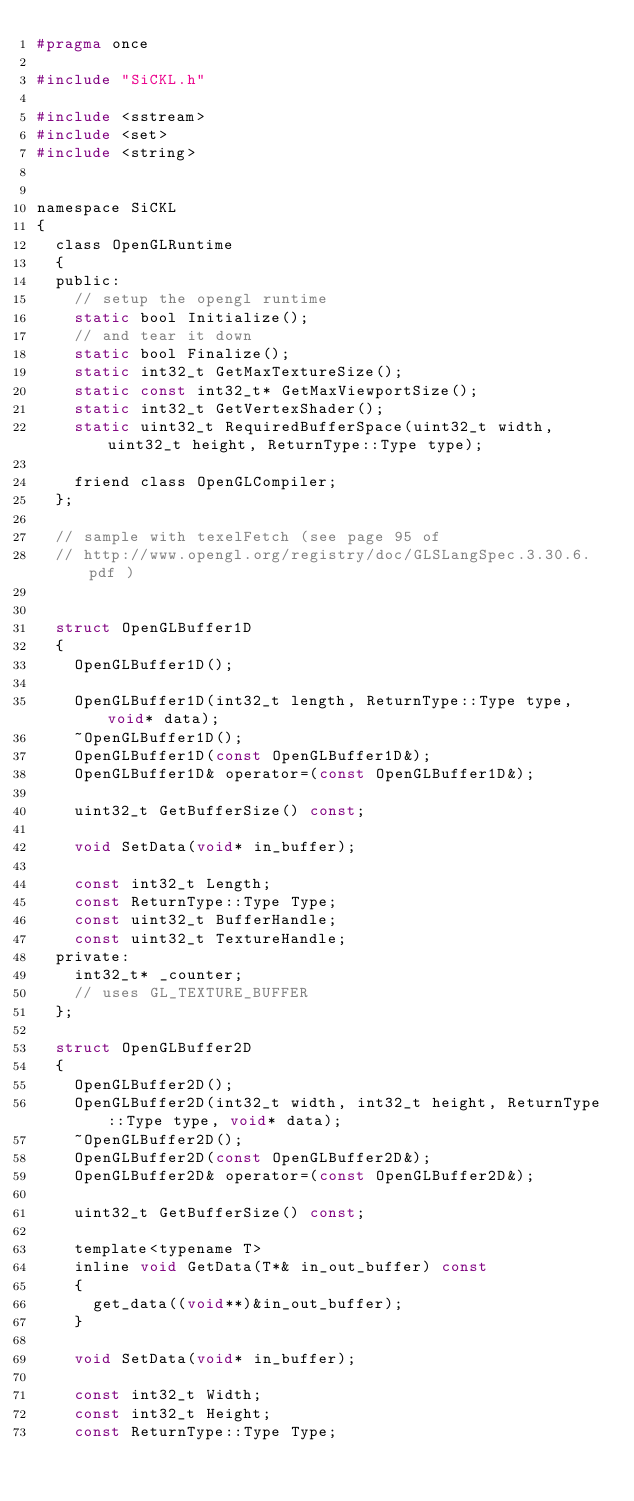Convert code to text. <code><loc_0><loc_0><loc_500><loc_500><_C_>#pragma once

#include "SiCKL.h"

#include <sstream>
#include <set>
#include <string>


namespace SiCKL
{
	class OpenGLRuntime
	{
	public:
		// setup the opengl runtime
		static bool Initialize();
		// and tear it down
		static bool Finalize();
		static int32_t GetMaxTextureSize();
		static const int32_t* GetMaxViewportSize();
		static int32_t GetVertexShader();
		static uint32_t RequiredBufferSpace(uint32_t width, uint32_t height, ReturnType::Type type);

		friend class OpenGLCompiler;
	};

	// sample with texelFetch (see page 95 of 
	// http://www.opengl.org/registry/doc/GLSLangSpec.3.30.6.pdf )
	
	
	struct OpenGLBuffer1D
	{
		OpenGLBuffer1D();

		OpenGLBuffer1D(int32_t length, ReturnType::Type type, void* data);
		~OpenGLBuffer1D();
		OpenGLBuffer1D(const OpenGLBuffer1D&);
		OpenGLBuffer1D& operator=(const OpenGLBuffer1D&);

		uint32_t GetBufferSize() const;

		void SetData(void* in_buffer);

		const int32_t Length;
		const ReturnType::Type Type;
		const uint32_t BufferHandle;
		const uint32_t TextureHandle;
	private:
		int32_t* _counter;
		// uses GL_TEXTURE_BUFFER
	};

	struct OpenGLBuffer2D
	{
		OpenGLBuffer2D();
		OpenGLBuffer2D(int32_t width, int32_t height, ReturnType::Type type, void* data);
		~OpenGLBuffer2D();
		OpenGLBuffer2D(const OpenGLBuffer2D&);
		OpenGLBuffer2D& operator=(const OpenGLBuffer2D&);
		
		uint32_t GetBufferSize() const;
		
		template<typename T>
		inline void GetData(T*& in_out_buffer) const
		{
			get_data((void**)&in_out_buffer);
		}

		void SetData(void* in_buffer);

		const int32_t Width;
		const int32_t Height;
		const ReturnType::Type Type;</code> 